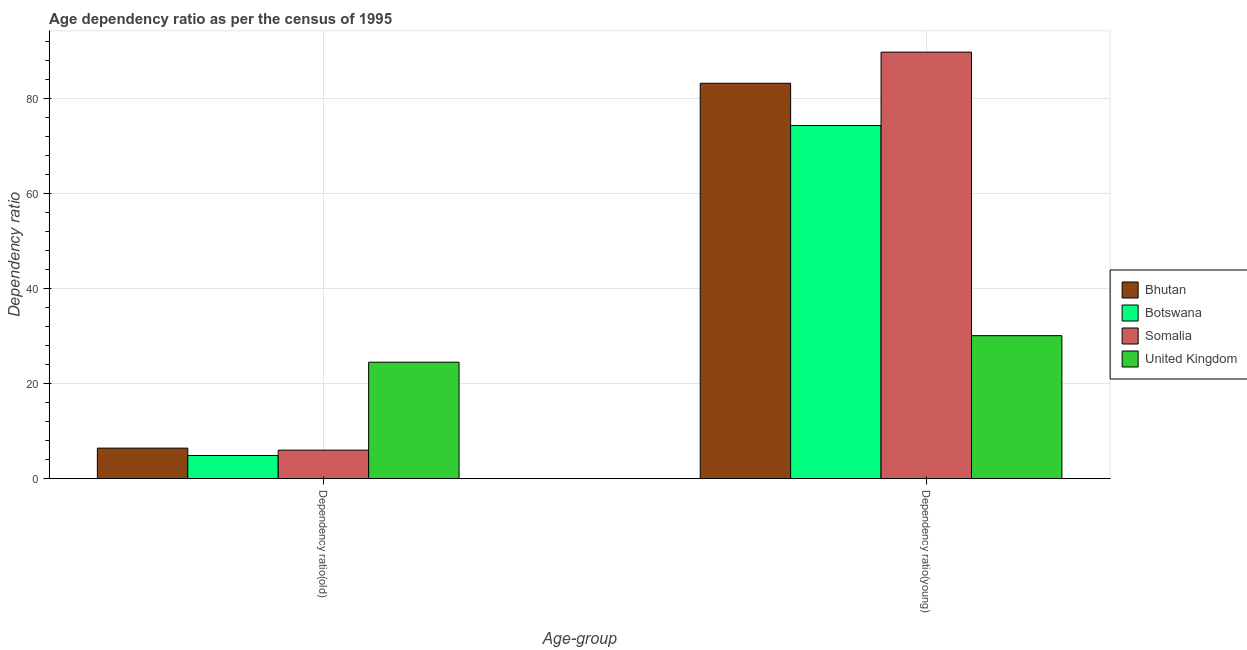What is the label of the 2nd group of bars from the left?
Give a very brief answer. Dependency ratio(young). What is the age dependency ratio(young) in Bhutan?
Ensure brevity in your answer.  83.25. Across all countries, what is the maximum age dependency ratio(young)?
Keep it short and to the point. 89.8. Across all countries, what is the minimum age dependency ratio(young)?
Provide a short and direct response. 30.1. In which country was the age dependency ratio(young) maximum?
Provide a succinct answer. Somalia. In which country was the age dependency ratio(old) minimum?
Give a very brief answer. Botswana. What is the total age dependency ratio(young) in the graph?
Provide a succinct answer. 277.51. What is the difference between the age dependency ratio(young) in Botswana and that in United Kingdom?
Provide a succinct answer. 44.24. What is the difference between the age dependency ratio(young) in Somalia and the age dependency ratio(old) in Bhutan?
Provide a short and direct response. 83.39. What is the average age dependency ratio(young) per country?
Provide a short and direct response. 69.38. What is the difference between the age dependency ratio(young) and age dependency ratio(old) in Bhutan?
Keep it short and to the point. 76.83. In how many countries, is the age dependency ratio(young) greater than 64 ?
Ensure brevity in your answer.  3. What is the ratio of the age dependency ratio(young) in United Kingdom to that in Somalia?
Make the answer very short. 0.34. In how many countries, is the age dependency ratio(old) greater than the average age dependency ratio(old) taken over all countries?
Your answer should be compact. 1. What does the 2nd bar from the left in Dependency ratio(young) represents?
Your answer should be very brief. Botswana. What does the 4th bar from the right in Dependency ratio(young) represents?
Offer a very short reply. Bhutan. How many bars are there?
Ensure brevity in your answer.  8. Are all the bars in the graph horizontal?
Give a very brief answer. No. How many countries are there in the graph?
Make the answer very short. 4. What is the difference between two consecutive major ticks on the Y-axis?
Make the answer very short. 20. Are the values on the major ticks of Y-axis written in scientific E-notation?
Give a very brief answer. No. Where does the legend appear in the graph?
Ensure brevity in your answer.  Center right. How many legend labels are there?
Give a very brief answer. 4. How are the legend labels stacked?
Your response must be concise. Vertical. What is the title of the graph?
Ensure brevity in your answer.  Age dependency ratio as per the census of 1995. Does "Somalia" appear as one of the legend labels in the graph?
Provide a succinct answer. Yes. What is the label or title of the X-axis?
Provide a succinct answer. Age-group. What is the label or title of the Y-axis?
Your response must be concise. Dependency ratio. What is the Dependency ratio in Bhutan in Dependency ratio(old)?
Offer a very short reply. 6.42. What is the Dependency ratio in Botswana in Dependency ratio(old)?
Make the answer very short. 4.86. What is the Dependency ratio in Somalia in Dependency ratio(old)?
Your response must be concise. 5.99. What is the Dependency ratio of United Kingdom in Dependency ratio(old)?
Provide a succinct answer. 24.51. What is the Dependency ratio in Bhutan in Dependency ratio(young)?
Your response must be concise. 83.25. What is the Dependency ratio of Botswana in Dependency ratio(young)?
Offer a terse response. 74.35. What is the Dependency ratio of Somalia in Dependency ratio(young)?
Offer a very short reply. 89.8. What is the Dependency ratio of United Kingdom in Dependency ratio(young)?
Give a very brief answer. 30.1. Across all Age-group, what is the maximum Dependency ratio in Bhutan?
Provide a succinct answer. 83.25. Across all Age-group, what is the maximum Dependency ratio in Botswana?
Give a very brief answer. 74.35. Across all Age-group, what is the maximum Dependency ratio in Somalia?
Give a very brief answer. 89.8. Across all Age-group, what is the maximum Dependency ratio in United Kingdom?
Ensure brevity in your answer.  30.1. Across all Age-group, what is the minimum Dependency ratio of Bhutan?
Keep it short and to the point. 6.42. Across all Age-group, what is the minimum Dependency ratio of Botswana?
Offer a very short reply. 4.86. Across all Age-group, what is the minimum Dependency ratio in Somalia?
Your answer should be compact. 5.99. Across all Age-group, what is the minimum Dependency ratio of United Kingdom?
Make the answer very short. 24.51. What is the total Dependency ratio of Bhutan in the graph?
Keep it short and to the point. 89.67. What is the total Dependency ratio of Botswana in the graph?
Your response must be concise. 79.21. What is the total Dependency ratio of Somalia in the graph?
Ensure brevity in your answer.  95.8. What is the total Dependency ratio in United Kingdom in the graph?
Offer a very short reply. 54.62. What is the difference between the Dependency ratio in Bhutan in Dependency ratio(old) and that in Dependency ratio(young)?
Your response must be concise. -76.83. What is the difference between the Dependency ratio in Botswana in Dependency ratio(old) and that in Dependency ratio(young)?
Make the answer very short. -69.48. What is the difference between the Dependency ratio in Somalia in Dependency ratio(old) and that in Dependency ratio(young)?
Keep it short and to the point. -83.81. What is the difference between the Dependency ratio of United Kingdom in Dependency ratio(old) and that in Dependency ratio(young)?
Provide a short and direct response. -5.59. What is the difference between the Dependency ratio in Bhutan in Dependency ratio(old) and the Dependency ratio in Botswana in Dependency ratio(young)?
Ensure brevity in your answer.  -67.93. What is the difference between the Dependency ratio of Bhutan in Dependency ratio(old) and the Dependency ratio of Somalia in Dependency ratio(young)?
Give a very brief answer. -83.39. What is the difference between the Dependency ratio in Bhutan in Dependency ratio(old) and the Dependency ratio in United Kingdom in Dependency ratio(young)?
Provide a short and direct response. -23.69. What is the difference between the Dependency ratio of Botswana in Dependency ratio(old) and the Dependency ratio of Somalia in Dependency ratio(young)?
Your answer should be compact. -84.94. What is the difference between the Dependency ratio in Botswana in Dependency ratio(old) and the Dependency ratio in United Kingdom in Dependency ratio(young)?
Provide a succinct answer. -25.24. What is the difference between the Dependency ratio in Somalia in Dependency ratio(old) and the Dependency ratio in United Kingdom in Dependency ratio(young)?
Provide a succinct answer. -24.11. What is the average Dependency ratio in Bhutan per Age-group?
Provide a short and direct response. 44.83. What is the average Dependency ratio of Botswana per Age-group?
Give a very brief answer. 39.61. What is the average Dependency ratio in Somalia per Age-group?
Your response must be concise. 47.9. What is the average Dependency ratio of United Kingdom per Age-group?
Keep it short and to the point. 27.31. What is the difference between the Dependency ratio in Bhutan and Dependency ratio in Botswana in Dependency ratio(old)?
Your response must be concise. 1.55. What is the difference between the Dependency ratio in Bhutan and Dependency ratio in Somalia in Dependency ratio(old)?
Your answer should be very brief. 0.43. What is the difference between the Dependency ratio of Bhutan and Dependency ratio of United Kingdom in Dependency ratio(old)?
Provide a succinct answer. -18.1. What is the difference between the Dependency ratio of Botswana and Dependency ratio of Somalia in Dependency ratio(old)?
Keep it short and to the point. -1.13. What is the difference between the Dependency ratio of Botswana and Dependency ratio of United Kingdom in Dependency ratio(old)?
Your response must be concise. -19.65. What is the difference between the Dependency ratio of Somalia and Dependency ratio of United Kingdom in Dependency ratio(old)?
Your response must be concise. -18.52. What is the difference between the Dependency ratio of Bhutan and Dependency ratio of Botswana in Dependency ratio(young)?
Your answer should be compact. 8.9. What is the difference between the Dependency ratio in Bhutan and Dependency ratio in Somalia in Dependency ratio(young)?
Make the answer very short. -6.55. What is the difference between the Dependency ratio in Bhutan and Dependency ratio in United Kingdom in Dependency ratio(young)?
Ensure brevity in your answer.  53.15. What is the difference between the Dependency ratio in Botswana and Dependency ratio in Somalia in Dependency ratio(young)?
Offer a terse response. -15.46. What is the difference between the Dependency ratio of Botswana and Dependency ratio of United Kingdom in Dependency ratio(young)?
Keep it short and to the point. 44.24. What is the difference between the Dependency ratio in Somalia and Dependency ratio in United Kingdom in Dependency ratio(young)?
Your answer should be compact. 59.7. What is the ratio of the Dependency ratio in Bhutan in Dependency ratio(old) to that in Dependency ratio(young)?
Offer a very short reply. 0.08. What is the ratio of the Dependency ratio of Botswana in Dependency ratio(old) to that in Dependency ratio(young)?
Provide a succinct answer. 0.07. What is the ratio of the Dependency ratio of Somalia in Dependency ratio(old) to that in Dependency ratio(young)?
Keep it short and to the point. 0.07. What is the ratio of the Dependency ratio in United Kingdom in Dependency ratio(old) to that in Dependency ratio(young)?
Provide a short and direct response. 0.81. What is the difference between the highest and the second highest Dependency ratio in Bhutan?
Provide a short and direct response. 76.83. What is the difference between the highest and the second highest Dependency ratio of Botswana?
Keep it short and to the point. 69.48. What is the difference between the highest and the second highest Dependency ratio in Somalia?
Provide a succinct answer. 83.81. What is the difference between the highest and the second highest Dependency ratio in United Kingdom?
Keep it short and to the point. 5.59. What is the difference between the highest and the lowest Dependency ratio of Bhutan?
Your answer should be very brief. 76.83. What is the difference between the highest and the lowest Dependency ratio in Botswana?
Make the answer very short. 69.48. What is the difference between the highest and the lowest Dependency ratio of Somalia?
Offer a terse response. 83.81. What is the difference between the highest and the lowest Dependency ratio in United Kingdom?
Give a very brief answer. 5.59. 